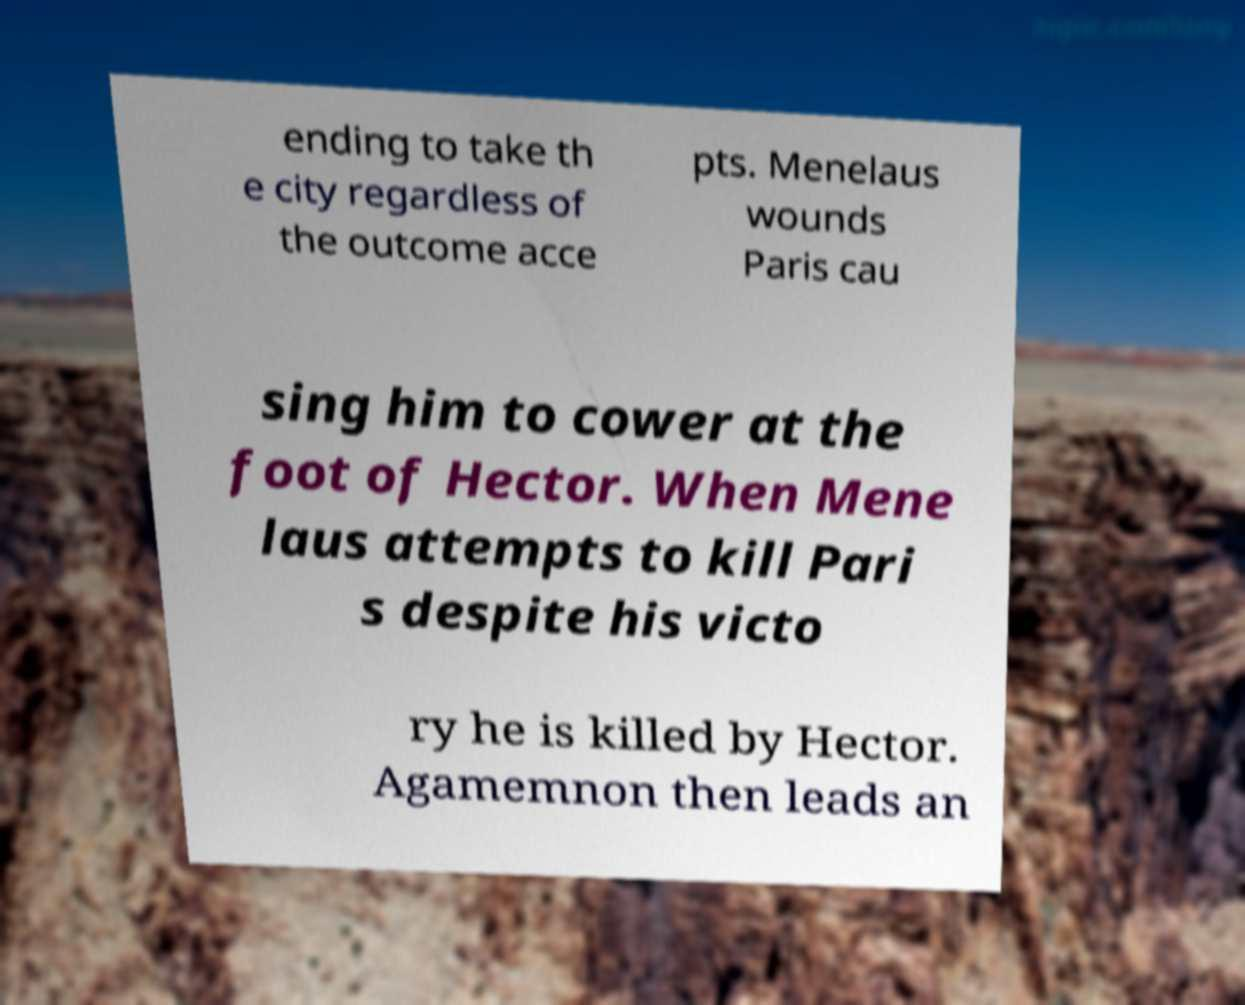There's text embedded in this image that I need extracted. Can you transcribe it verbatim? ending to take th e city regardless of the outcome acce pts. Menelaus wounds Paris cau sing him to cower at the foot of Hector. When Mene laus attempts to kill Pari s despite his victo ry he is killed by Hector. Agamemnon then leads an 